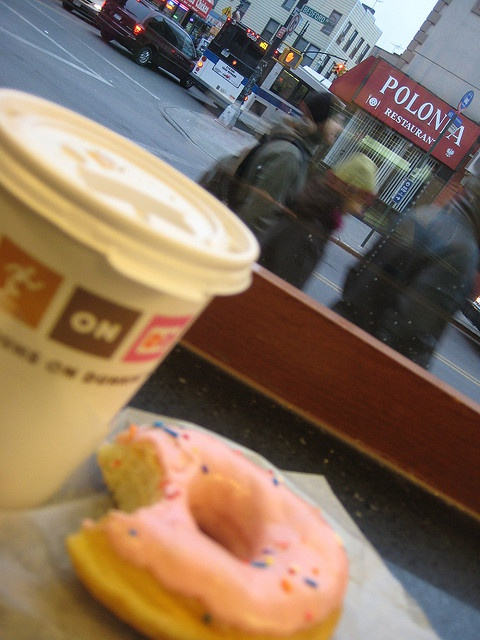Describe the objects in this image and their specific colors. I can see cup in gray, tan, and ivory tones, donut in gray, tan, lightpink, orange, and pink tones, people in gray, black, and blue tones, people in gray and black tones, and bus in gray, black, and lightblue tones in this image. 